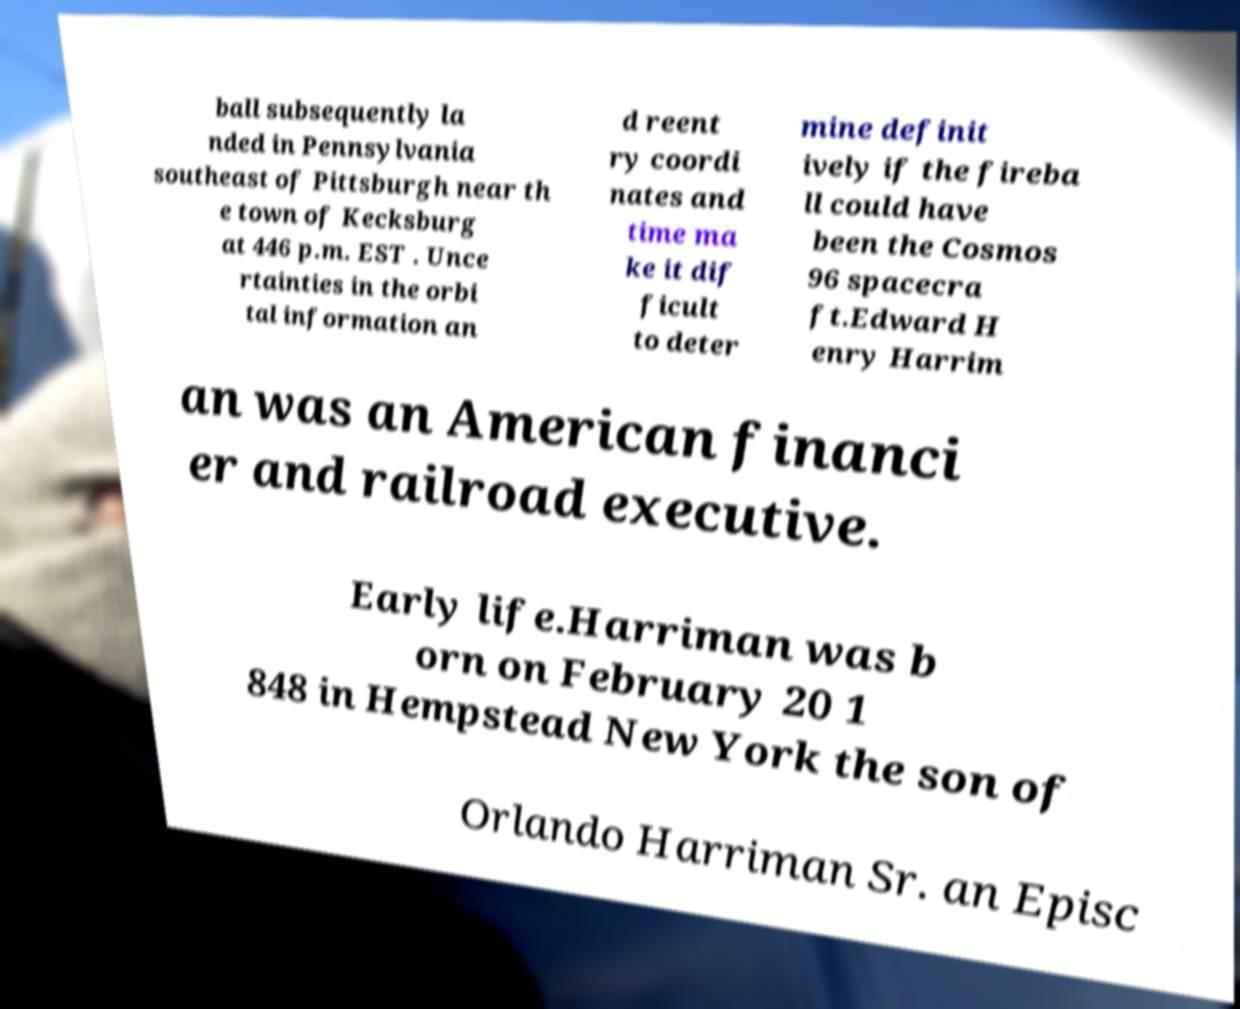I need the written content from this picture converted into text. Can you do that? ball subsequently la nded in Pennsylvania southeast of Pittsburgh near th e town of Kecksburg at 446 p.m. EST . Unce rtainties in the orbi tal information an d reent ry coordi nates and time ma ke it dif ficult to deter mine definit ively if the fireba ll could have been the Cosmos 96 spacecra ft.Edward H enry Harrim an was an American financi er and railroad executive. Early life.Harriman was b orn on February 20 1 848 in Hempstead New York the son of Orlando Harriman Sr. an Episc 